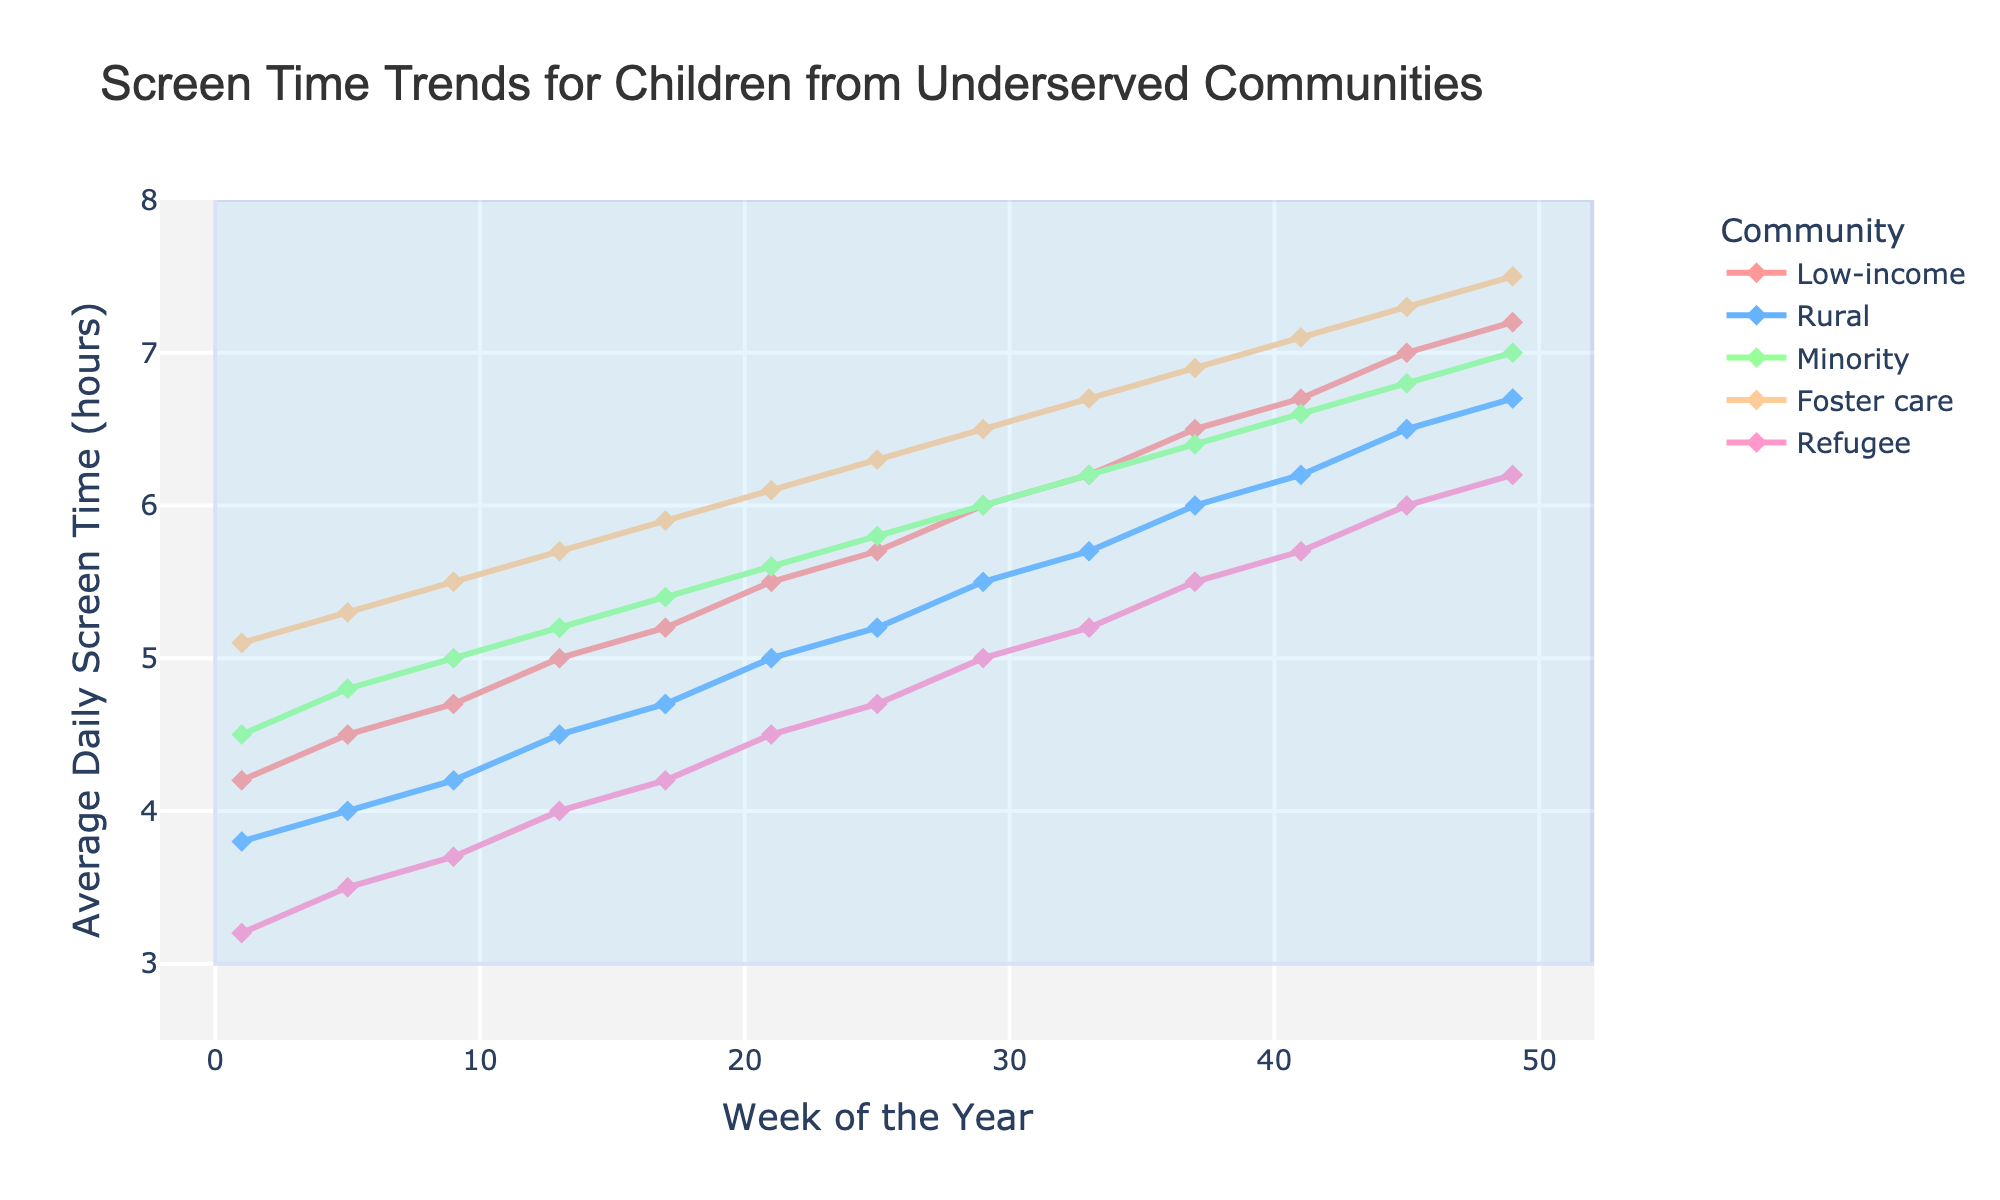What is the trend of screen time for children in foster care over the year? Looking at the purple line representing foster care, we see a steady increase from 5.1 hours in the first week to 7.5 hours in week 49.
Answer: Steady increase Which community has the lowest screen time in the first week? By examining the data points at week 1, we see that the refugee community (represented by cyan) has the lowest screen time at 3.2 hours.
Answer: Refugee At which week, and for which community, does screen time exceed 6 hours for the first time? We see that screen time for the foster care community exceeds 6 hours first in week 21.
Answer: Week 21, Foster care Compare the screen time trend for low-income and rural children. Low-income children's screen time starts higher and increases more significantly than rural children's. At week 1, it's 4.2 for low-income and 3.8 for rural children. By week 49, it's 7.2 for low-income and 6.7 for rural children.
Answer: Low-income rises faster What is the average screen time for minority children over the year? To find the average, add the screen time values for minority children across all weeks and divide by the number of weeks. The sum is (4.5 + 4.8 + 5.0 + 5.2 + 5.4 + 5.6 + 5.8 + 6.0 + 6.2 + 6.4 + 6.6 + 6.8 + 7.0) = 74.3. There are 13 weeks recorded, so the average is 74.3 / 13 = 5.72 hours.
Answer: 5.72 hours During which weeks is screen time for all groups between 3 and 8 hours? The shaded region between 3 and 8 hours represents the range of interest. All groups' screen time remains within this range for all weeks shown in the dataset.
Answer: All weeks Which community shows the most consistent week-to-week increase in screen time? Foster care children (purple line) have the most consistent week-to-week increase, with screen time rising steadily without any dips or plateaus.
Answer: Foster care How does the screen time for refugee children change from week 1 to week 49? Refugee children’s screen time increases from 3.2 hours in week 1 to 6.2 hours in week 49. This is a net increase of (6.2 - 3.2 = 3) hours.
Answer: Increases by 3 hours Which community had a screen time of approximately 5 hours at week 25? By looking at the data for week 25, rural community children have about 5.2 hours of screen time, which is closest to 5 hours.
Answer: Rural At what week does the screen time for the low-income group reach 7 hours, and what is the screen time for the refugee group at the same week? At week 45, the low-income group's screen time reaches 7 hours. At this same week, the refugee group's screen time is 6 hours.
Answer: Week 45, 6 hours 